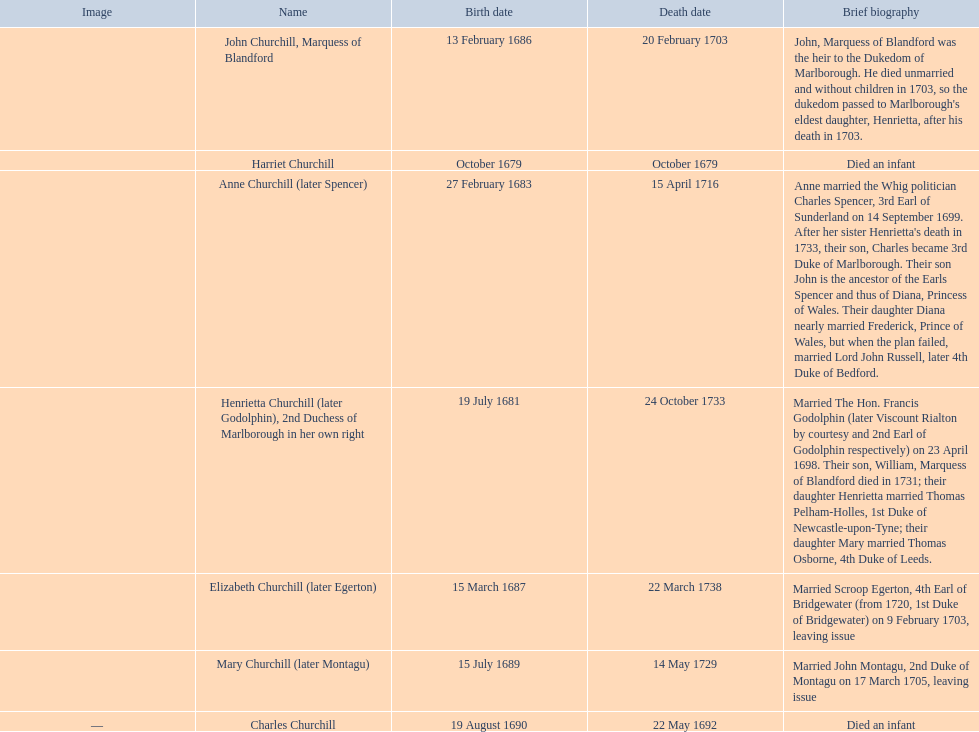Which child was the first to die? Harriet Churchill. 